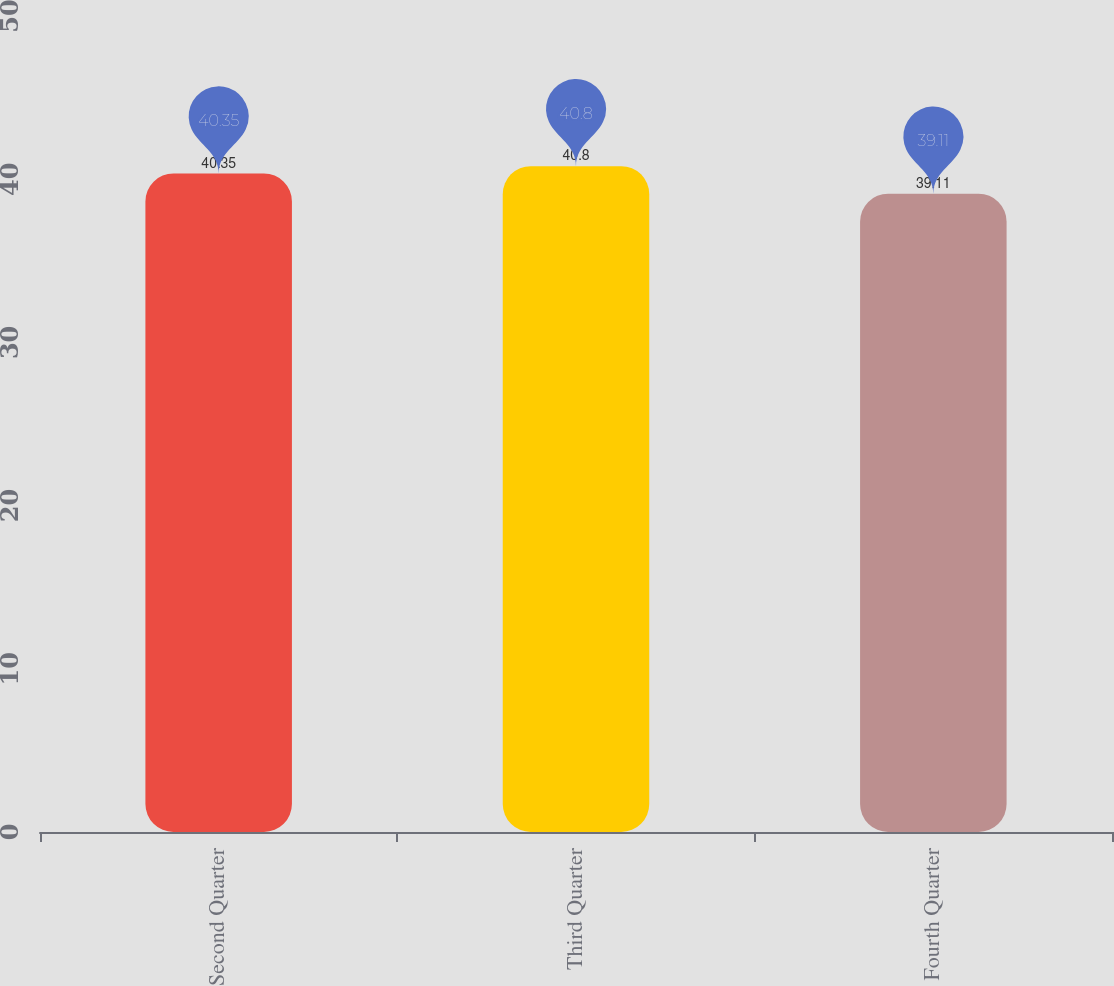Convert chart. <chart><loc_0><loc_0><loc_500><loc_500><bar_chart><fcel>Second Quarter<fcel>Third Quarter<fcel>Fourth Quarter<nl><fcel>40.35<fcel>40.8<fcel>39.11<nl></chart> 